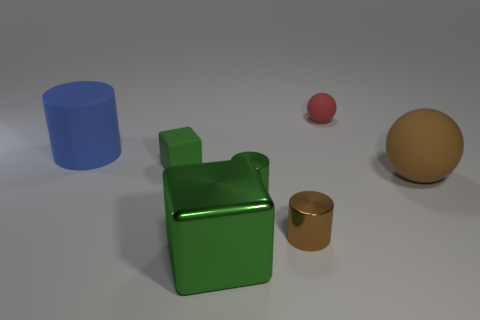What could be the purpose of these objects, and do they interact with each other in any way? The objects appear to be simplistic geometric shapes placed for a display, perhaps as part of a visualization or a study in color and form. They do not interact with each other physically, but visually, they create a harmonious array of shapes and colors that interact with the viewer's perception of space and composition. 